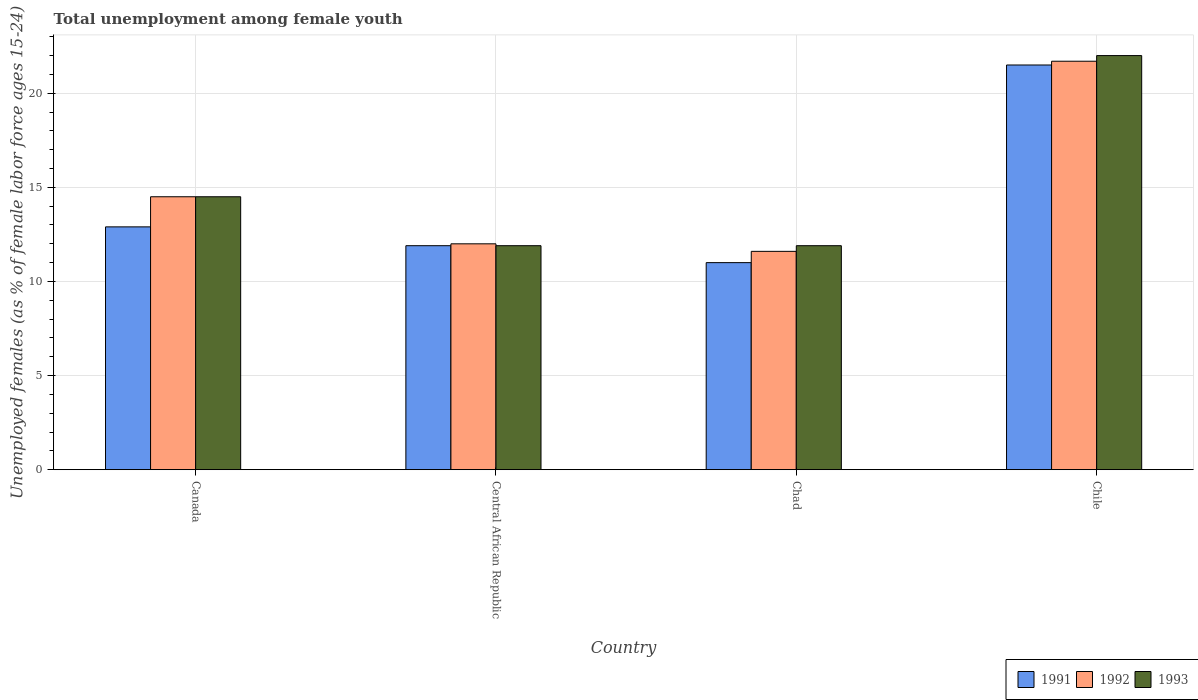How many groups of bars are there?
Offer a very short reply. 4. Are the number of bars per tick equal to the number of legend labels?
Make the answer very short. Yes. How many bars are there on the 4th tick from the left?
Your response must be concise. 3. Across all countries, what is the maximum percentage of unemployed females in in 1992?
Offer a terse response. 21.7. Across all countries, what is the minimum percentage of unemployed females in in 1992?
Give a very brief answer. 11.6. In which country was the percentage of unemployed females in in 1993 maximum?
Offer a terse response. Chile. In which country was the percentage of unemployed females in in 1991 minimum?
Your answer should be very brief. Chad. What is the total percentage of unemployed females in in 1992 in the graph?
Ensure brevity in your answer.  59.8. What is the difference between the percentage of unemployed females in in 1992 in Central African Republic and that in Chad?
Keep it short and to the point. 0.4. What is the difference between the percentage of unemployed females in in 1991 in Chile and the percentage of unemployed females in in 1993 in Chad?
Make the answer very short. 9.6. What is the average percentage of unemployed females in in 1993 per country?
Your answer should be very brief. 15.07. What is the difference between the percentage of unemployed females in of/in 1993 and percentage of unemployed females in of/in 1992 in Chile?
Offer a very short reply. 0.3. What is the ratio of the percentage of unemployed females in in 1991 in Central African Republic to that in Chile?
Give a very brief answer. 0.55. What is the difference between the highest and the second highest percentage of unemployed females in in 1991?
Provide a succinct answer. -1. What is the difference between the highest and the lowest percentage of unemployed females in in 1992?
Ensure brevity in your answer.  10.1. Is the sum of the percentage of unemployed females in in 1993 in Chad and Chile greater than the maximum percentage of unemployed females in in 1992 across all countries?
Your response must be concise. Yes. What does the 2nd bar from the left in Central African Republic represents?
Give a very brief answer. 1992. How many bars are there?
Provide a short and direct response. 12. Are all the bars in the graph horizontal?
Provide a short and direct response. No. How many countries are there in the graph?
Your answer should be very brief. 4. How many legend labels are there?
Ensure brevity in your answer.  3. What is the title of the graph?
Your answer should be compact. Total unemployment among female youth. Does "1992" appear as one of the legend labels in the graph?
Your answer should be very brief. Yes. What is the label or title of the X-axis?
Give a very brief answer. Country. What is the label or title of the Y-axis?
Your answer should be very brief. Unemployed females (as % of female labor force ages 15-24). What is the Unemployed females (as % of female labor force ages 15-24) in 1991 in Canada?
Offer a very short reply. 12.9. What is the Unemployed females (as % of female labor force ages 15-24) of 1992 in Canada?
Offer a very short reply. 14.5. What is the Unemployed females (as % of female labor force ages 15-24) of 1993 in Canada?
Your answer should be very brief. 14.5. What is the Unemployed females (as % of female labor force ages 15-24) in 1991 in Central African Republic?
Your answer should be very brief. 11.9. What is the Unemployed females (as % of female labor force ages 15-24) in 1993 in Central African Republic?
Offer a terse response. 11.9. What is the Unemployed females (as % of female labor force ages 15-24) in 1992 in Chad?
Give a very brief answer. 11.6. What is the Unemployed females (as % of female labor force ages 15-24) of 1993 in Chad?
Give a very brief answer. 11.9. What is the Unemployed females (as % of female labor force ages 15-24) of 1991 in Chile?
Your answer should be very brief. 21.5. What is the Unemployed females (as % of female labor force ages 15-24) in 1992 in Chile?
Keep it short and to the point. 21.7. What is the Unemployed females (as % of female labor force ages 15-24) in 1993 in Chile?
Offer a very short reply. 22. Across all countries, what is the maximum Unemployed females (as % of female labor force ages 15-24) in 1991?
Ensure brevity in your answer.  21.5. Across all countries, what is the maximum Unemployed females (as % of female labor force ages 15-24) of 1992?
Offer a very short reply. 21.7. Across all countries, what is the maximum Unemployed females (as % of female labor force ages 15-24) in 1993?
Provide a succinct answer. 22. Across all countries, what is the minimum Unemployed females (as % of female labor force ages 15-24) in 1992?
Offer a terse response. 11.6. Across all countries, what is the minimum Unemployed females (as % of female labor force ages 15-24) in 1993?
Ensure brevity in your answer.  11.9. What is the total Unemployed females (as % of female labor force ages 15-24) of 1991 in the graph?
Provide a short and direct response. 57.3. What is the total Unemployed females (as % of female labor force ages 15-24) in 1992 in the graph?
Offer a very short reply. 59.8. What is the total Unemployed females (as % of female labor force ages 15-24) of 1993 in the graph?
Your answer should be compact. 60.3. What is the difference between the Unemployed females (as % of female labor force ages 15-24) of 1993 in Canada and that in Central African Republic?
Offer a terse response. 2.6. What is the difference between the Unemployed females (as % of female labor force ages 15-24) in 1991 in Canada and that in Chad?
Your answer should be compact. 1.9. What is the difference between the Unemployed females (as % of female labor force ages 15-24) of 1993 in Canada and that in Chad?
Give a very brief answer. 2.6. What is the difference between the Unemployed females (as % of female labor force ages 15-24) of 1991 in Canada and that in Chile?
Offer a terse response. -8.6. What is the difference between the Unemployed females (as % of female labor force ages 15-24) in 1991 in Central African Republic and that in Chad?
Your response must be concise. 0.9. What is the difference between the Unemployed females (as % of female labor force ages 15-24) of 1992 in Central African Republic and that in Chad?
Make the answer very short. 0.4. What is the difference between the Unemployed females (as % of female labor force ages 15-24) of 1992 in Central African Republic and that in Chile?
Your answer should be compact. -9.7. What is the difference between the Unemployed females (as % of female labor force ages 15-24) in 1992 in Chad and that in Chile?
Make the answer very short. -10.1. What is the difference between the Unemployed females (as % of female labor force ages 15-24) in 1993 in Chad and that in Chile?
Keep it short and to the point. -10.1. What is the difference between the Unemployed females (as % of female labor force ages 15-24) of 1991 in Canada and the Unemployed females (as % of female labor force ages 15-24) of 1993 in Central African Republic?
Provide a short and direct response. 1. What is the difference between the Unemployed females (as % of female labor force ages 15-24) in 1991 in Canada and the Unemployed females (as % of female labor force ages 15-24) in 1993 in Chad?
Your answer should be compact. 1. What is the difference between the Unemployed females (as % of female labor force ages 15-24) in 1992 in Canada and the Unemployed females (as % of female labor force ages 15-24) in 1993 in Chad?
Your answer should be compact. 2.6. What is the difference between the Unemployed females (as % of female labor force ages 15-24) of 1992 in Canada and the Unemployed females (as % of female labor force ages 15-24) of 1993 in Chile?
Make the answer very short. -7.5. What is the difference between the Unemployed females (as % of female labor force ages 15-24) in 1992 in Central African Republic and the Unemployed females (as % of female labor force ages 15-24) in 1993 in Chad?
Keep it short and to the point. 0.1. What is the difference between the Unemployed females (as % of female labor force ages 15-24) in 1991 in Central African Republic and the Unemployed females (as % of female labor force ages 15-24) in 1992 in Chile?
Provide a succinct answer. -9.8. What is the difference between the Unemployed females (as % of female labor force ages 15-24) in 1991 in Central African Republic and the Unemployed females (as % of female labor force ages 15-24) in 1993 in Chile?
Offer a very short reply. -10.1. What is the difference between the Unemployed females (as % of female labor force ages 15-24) in 1992 in Central African Republic and the Unemployed females (as % of female labor force ages 15-24) in 1993 in Chile?
Offer a very short reply. -10. What is the difference between the Unemployed females (as % of female labor force ages 15-24) of 1991 in Chad and the Unemployed females (as % of female labor force ages 15-24) of 1992 in Chile?
Your answer should be very brief. -10.7. What is the average Unemployed females (as % of female labor force ages 15-24) of 1991 per country?
Offer a very short reply. 14.32. What is the average Unemployed females (as % of female labor force ages 15-24) of 1992 per country?
Provide a succinct answer. 14.95. What is the average Unemployed females (as % of female labor force ages 15-24) in 1993 per country?
Provide a succinct answer. 15.07. What is the difference between the Unemployed females (as % of female labor force ages 15-24) in 1991 and Unemployed females (as % of female labor force ages 15-24) in 1992 in Canada?
Provide a succinct answer. -1.6. What is the difference between the Unemployed females (as % of female labor force ages 15-24) in 1991 and Unemployed females (as % of female labor force ages 15-24) in 1993 in Central African Republic?
Offer a terse response. 0. What is the difference between the Unemployed females (as % of female labor force ages 15-24) in 1992 and Unemployed females (as % of female labor force ages 15-24) in 1993 in Central African Republic?
Provide a short and direct response. 0.1. What is the difference between the Unemployed females (as % of female labor force ages 15-24) in 1991 and Unemployed females (as % of female labor force ages 15-24) in 1993 in Chad?
Offer a very short reply. -0.9. What is the difference between the Unemployed females (as % of female labor force ages 15-24) in 1992 and Unemployed females (as % of female labor force ages 15-24) in 1993 in Chad?
Offer a terse response. -0.3. What is the difference between the Unemployed females (as % of female labor force ages 15-24) of 1991 and Unemployed females (as % of female labor force ages 15-24) of 1992 in Chile?
Make the answer very short. -0.2. What is the difference between the Unemployed females (as % of female labor force ages 15-24) of 1991 and Unemployed females (as % of female labor force ages 15-24) of 1993 in Chile?
Offer a terse response. -0.5. What is the difference between the Unemployed females (as % of female labor force ages 15-24) in 1992 and Unemployed females (as % of female labor force ages 15-24) in 1993 in Chile?
Your response must be concise. -0.3. What is the ratio of the Unemployed females (as % of female labor force ages 15-24) of 1991 in Canada to that in Central African Republic?
Provide a succinct answer. 1.08. What is the ratio of the Unemployed females (as % of female labor force ages 15-24) of 1992 in Canada to that in Central African Republic?
Make the answer very short. 1.21. What is the ratio of the Unemployed females (as % of female labor force ages 15-24) in 1993 in Canada to that in Central African Republic?
Your response must be concise. 1.22. What is the ratio of the Unemployed females (as % of female labor force ages 15-24) in 1991 in Canada to that in Chad?
Give a very brief answer. 1.17. What is the ratio of the Unemployed females (as % of female labor force ages 15-24) in 1992 in Canada to that in Chad?
Your response must be concise. 1.25. What is the ratio of the Unemployed females (as % of female labor force ages 15-24) in 1993 in Canada to that in Chad?
Give a very brief answer. 1.22. What is the ratio of the Unemployed females (as % of female labor force ages 15-24) in 1991 in Canada to that in Chile?
Provide a succinct answer. 0.6. What is the ratio of the Unemployed females (as % of female labor force ages 15-24) in 1992 in Canada to that in Chile?
Offer a terse response. 0.67. What is the ratio of the Unemployed females (as % of female labor force ages 15-24) in 1993 in Canada to that in Chile?
Offer a very short reply. 0.66. What is the ratio of the Unemployed females (as % of female labor force ages 15-24) of 1991 in Central African Republic to that in Chad?
Your response must be concise. 1.08. What is the ratio of the Unemployed females (as % of female labor force ages 15-24) in 1992 in Central African Republic to that in Chad?
Offer a terse response. 1.03. What is the ratio of the Unemployed females (as % of female labor force ages 15-24) in 1993 in Central African Republic to that in Chad?
Your response must be concise. 1. What is the ratio of the Unemployed females (as % of female labor force ages 15-24) of 1991 in Central African Republic to that in Chile?
Your answer should be compact. 0.55. What is the ratio of the Unemployed females (as % of female labor force ages 15-24) in 1992 in Central African Republic to that in Chile?
Keep it short and to the point. 0.55. What is the ratio of the Unemployed females (as % of female labor force ages 15-24) in 1993 in Central African Republic to that in Chile?
Your answer should be very brief. 0.54. What is the ratio of the Unemployed females (as % of female labor force ages 15-24) in 1991 in Chad to that in Chile?
Your answer should be very brief. 0.51. What is the ratio of the Unemployed females (as % of female labor force ages 15-24) of 1992 in Chad to that in Chile?
Provide a short and direct response. 0.53. What is the ratio of the Unemployed females (as % of female labor force ages 15-24) of 1993 in Chad to that in Chile?
Make the answer very short. 0.54. What is the difference between the highest and the second highest Unemployed females (as % of female labor force ages 15-24) in 1991?
Offer a terse response. 8.6. What is the difference between the highest and the second highest Unemployed females (as % of female labor force ages 15-24) in 1992?
Keep it short and to the point. 7.2. What is the difference between the highest and the second highest Unemployed females (as % of female labor force ages 15-24) in 1993?
Your answer should be very brief. 7.5. What is the difference between the highest and the lowest Unemployed females (as % of female labor force ages 15-24) of 1991?
Make the answer very short. 10.5. 